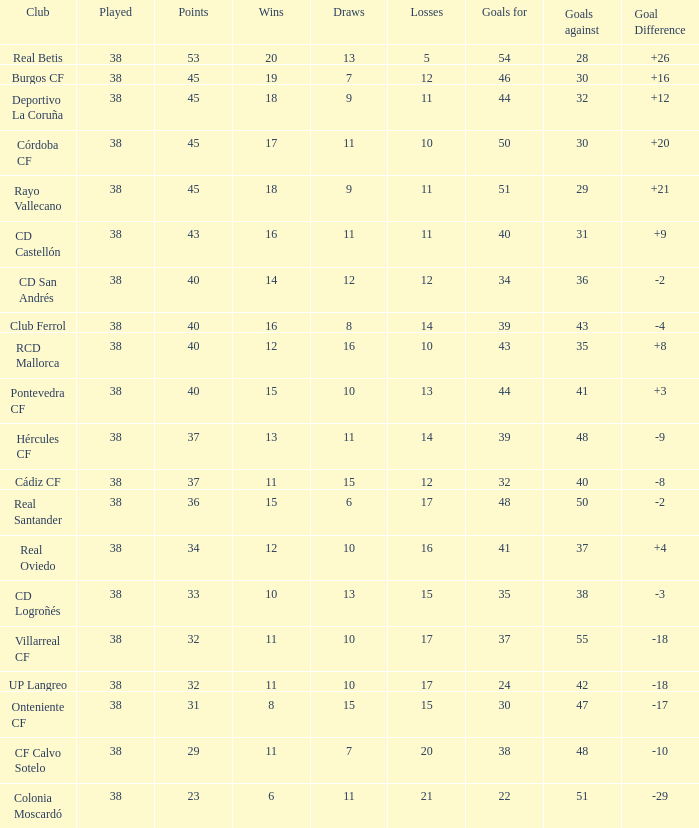For "burgos cf" club, what is the average number of played games when there are less than 7 draws? None. 